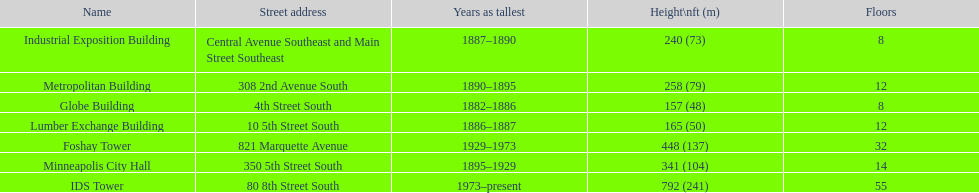Which building has 8 floors and is 240 ft tall? Industrial Exposition Building. 